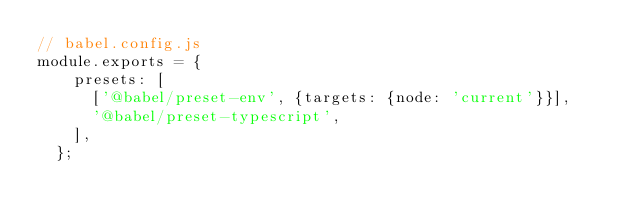<code> <loc_0><loc_0><loc_500><loc_500><_JavaScript_>// babel.config.js
module.exports = {
    presets: [
      ['@babel/preset-env', {targets: {node: 'current'}}],
      '@babel/preset-typescript',
    ],
  };</code> 